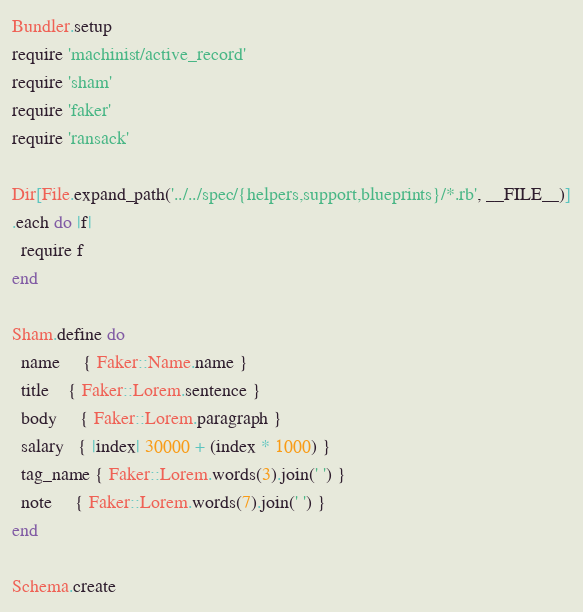Convert code to text. <code><loc_0><loc_0><loc_500><loc_500><_Ruby_>Bundler.setup
require 'machinist/active_record'
require 'sham'
require 'faker'
require 'ransack'

Dir[File.expand_path('../../spec/{helpers,support,blueprints}/*.rb', __FILE__)]
.each do |f|
  require f
end

Sham.define do
  name     { Faker::Name.name }
  title    { Faker::Lorem.sentence }
  body     { Faker::Lorem.paragraph }
  salary   { |index| 30000 + (index * 1000) }
  tag_name { Faker::Lorem.words(3).join(' ') }
  note     { Faker::Lorem.words(7).join(' ') }
end

Schema.create

</code> 